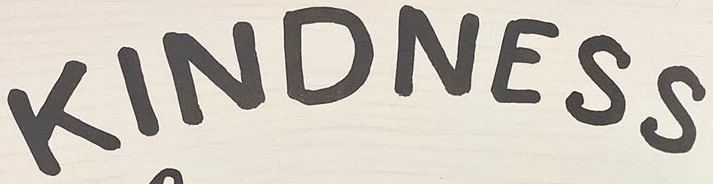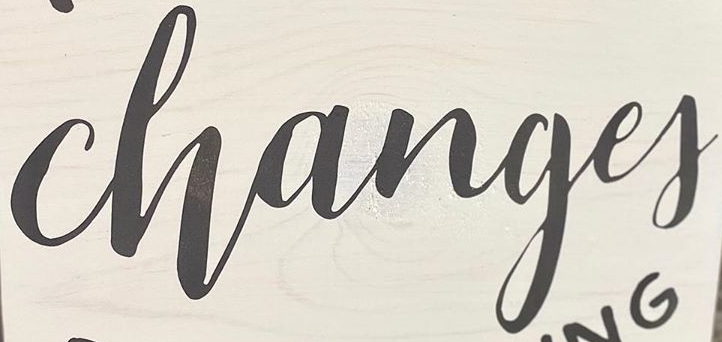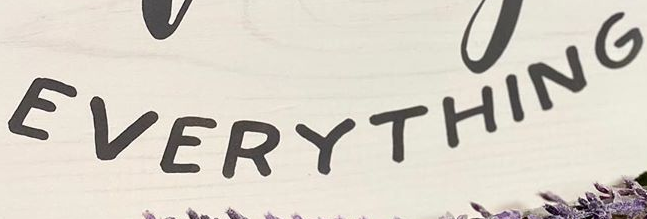Identify the words shown in these images in order, separated by a semicolon. KINDNESS; Changef; EVERYTHING 